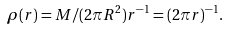Convert formula to latex. <formula><loc_0><loc_0><loc_500><loc_500>\rho ( r ) = M / ( 2 \pi R ^ { 2 } ) r ^ { - 1 } = ( 2 \pi r ) ^ { - 1 } .</formula> 